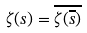<formula> <loc_0><loc_0><loc_500><loc_500>\zeta ( s ) = \overline { \zeta ( \overline { s } ) }</formula> 